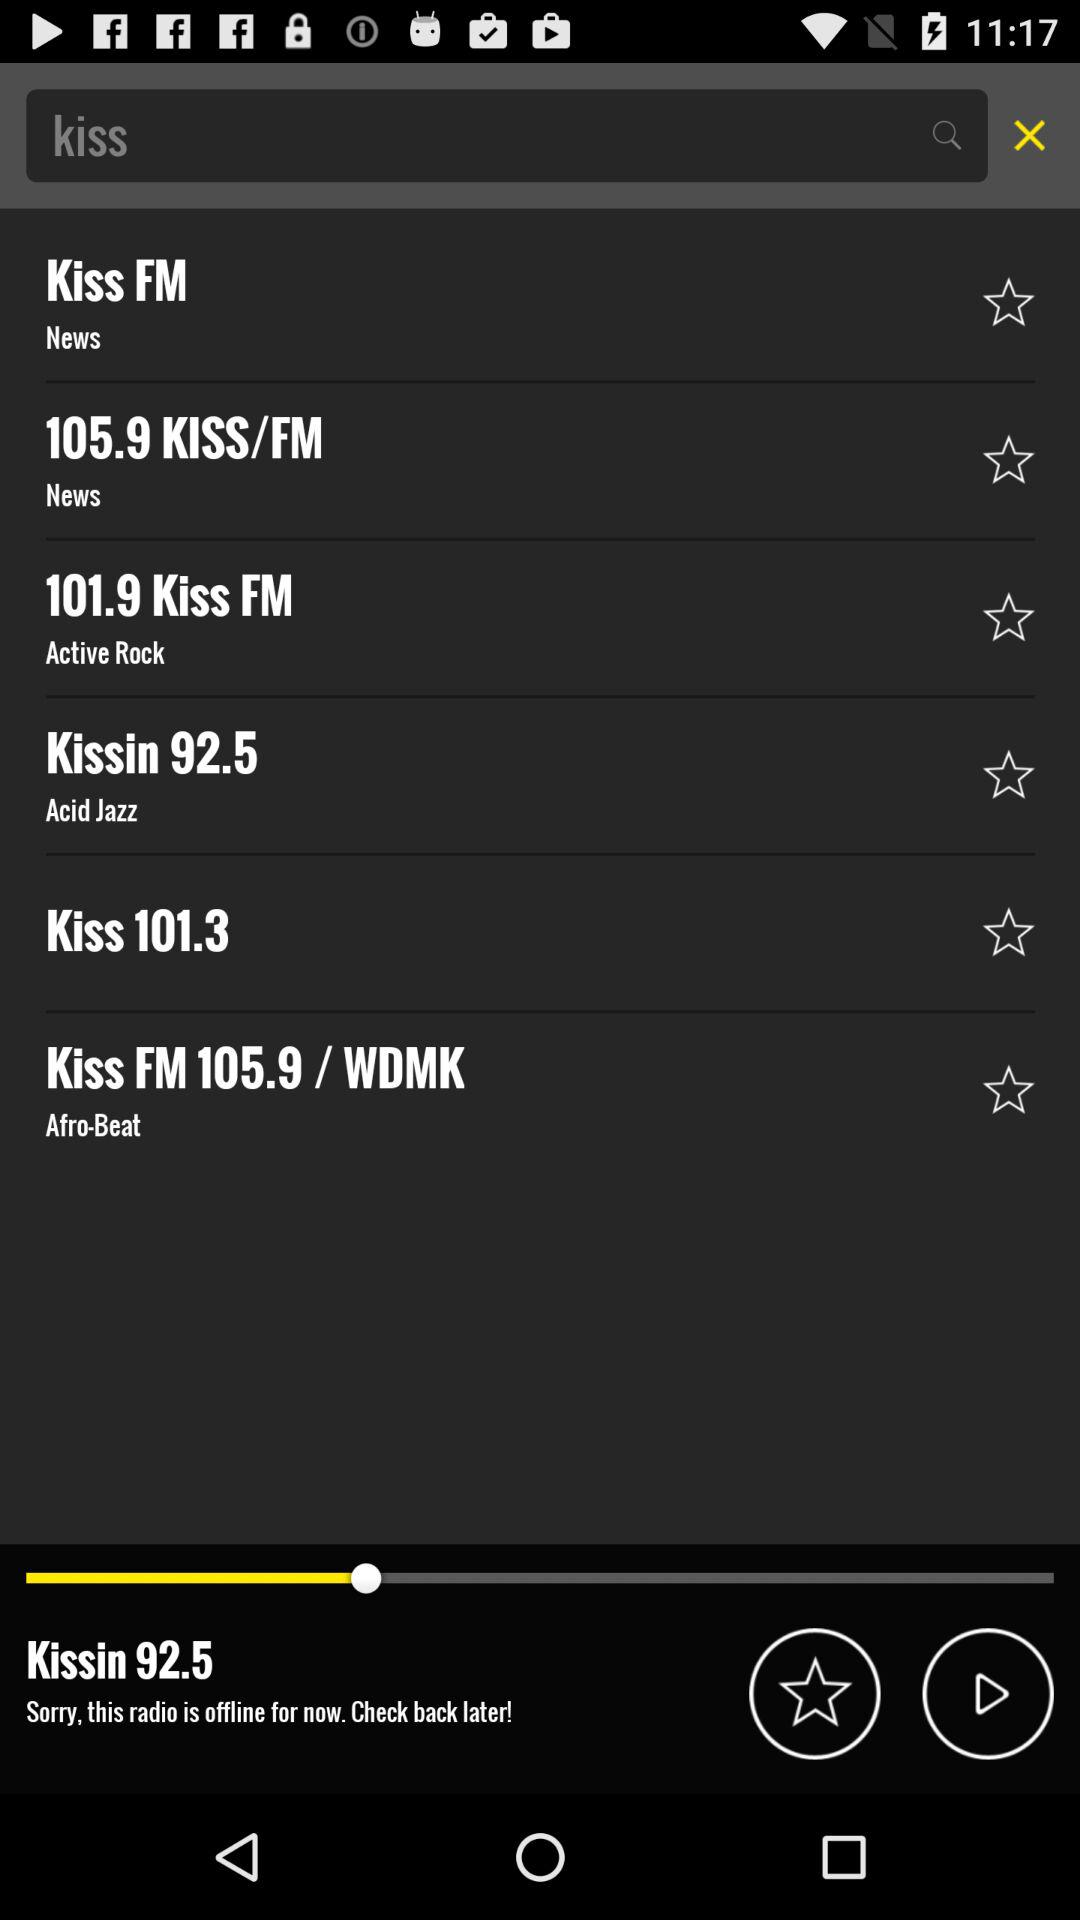How many radio stations are there?
Answer the question using a single word or phrase. 6 